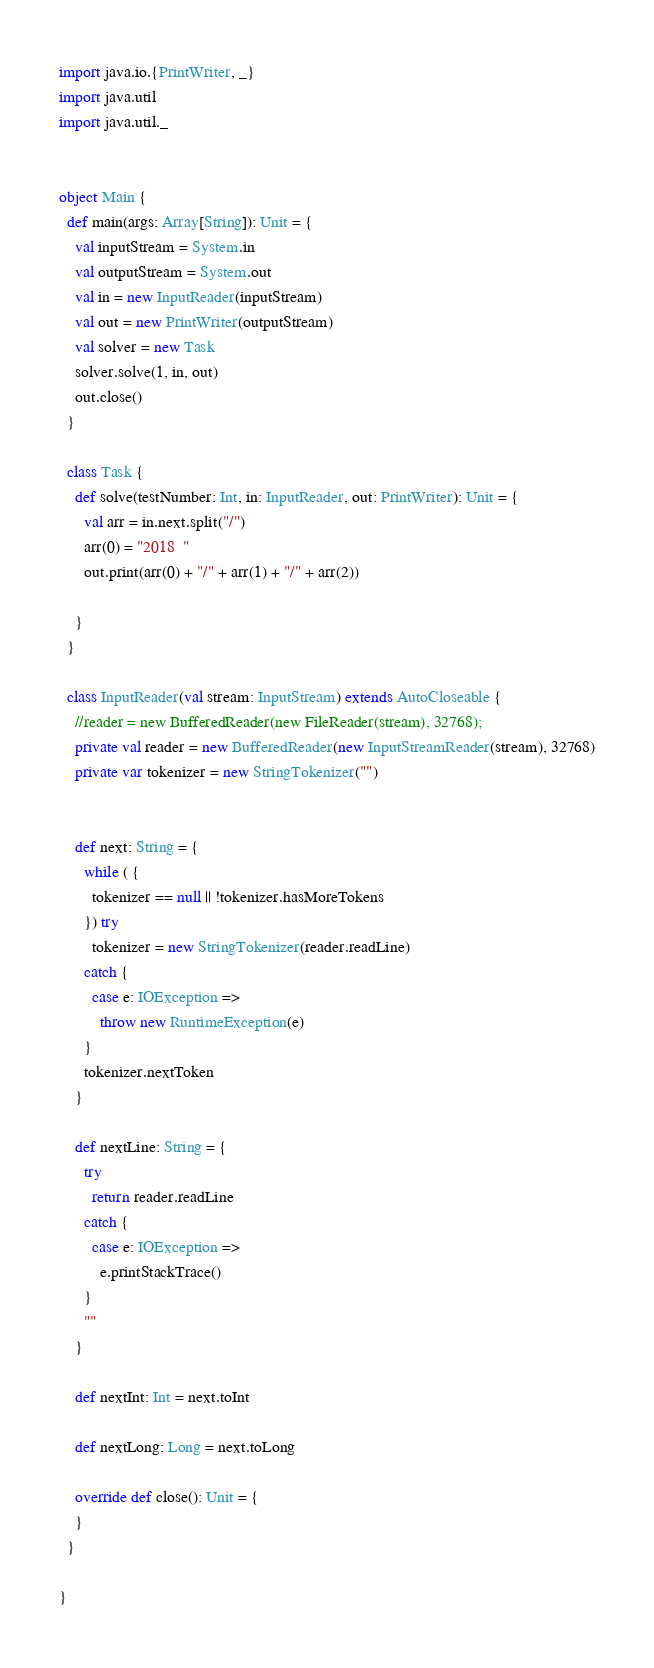<code> <loc_0><loc_0><loc_500><loc_500><_Scala_>import java.io.{PrintWriter, _}
import java.util
import java.util._


object Main {
  def main(args: Array[String]): Unit = {
    val inputStream = System.in
    val outputStream = System.out
    val in = new InputReader(inputStream)
    val out = new PrintWriter(outputStream)
    val solver = new Task
    solver.solve(1, in, out)
    out.close()
  }

  class Task {
    def solve(testNumber: Int, in: InputReader, out: PrintWriter): Unit = {
      val arr = in.next.split("/")
      arr(0) = "2018  "
      out.print(arr(0) + "/" + arr(1) + "/" + arr(2))

    }
  }

  class InputReader(val stream: InputStream) extends AutoCloseable {
    //reader = new BufferedReader(new FileReader(stream), 32768);
    private val reader = new BufferedReader(new InputStreamReader(stream), 32768)
    private var tokenizer = new StringTokenizer("")


    def next: String = {
      while ( {
        tokenizer == null || !tokenizer.hasMoreTokens
      }) try
        tokenizer = new StringTokenizer(reader.readLine)
      catch {
        case e: IOException =>
          throw new RuntimeException(e)
      }
      tokenizer.nextToken
    }

    def nextLine: String = {
      try
        return reader.readLine
      catch {
        case e: IOException =>
          e.printStackTrace()
      }
      ""
    }

    def nextInt: Int = next.toInt

    def nextLong: Long = next.toLong

    override def close(): Unit = {
    }
  }

}
</code> 